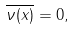<formula> <loc_0><loc_0><loc_500><loc_500>\overline { \nu ( x ) } = 0 ,</formula> 